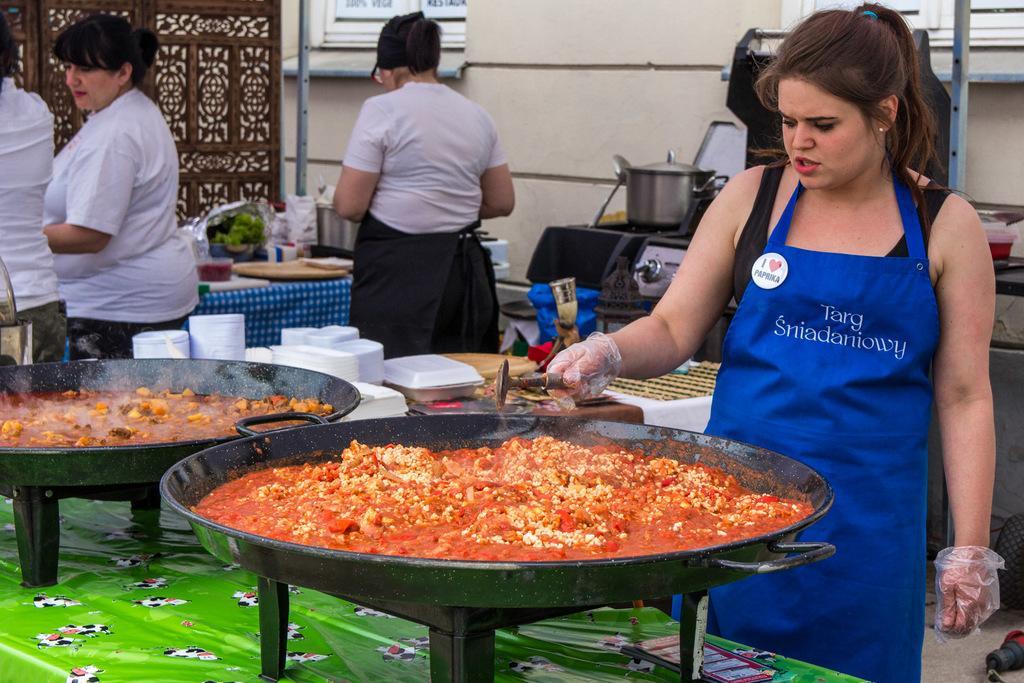Please provide a concise description of this image. In this picture we can see two pans on the table, there is some food in these pans, on the right side there is a woman standing and holding a spoon, we can see tables and three persons in the middle, there are some plates and other things present on these tables, in the background there is a wall and a window, on the right side we can see a spoon, a steel bowl and its cap. 